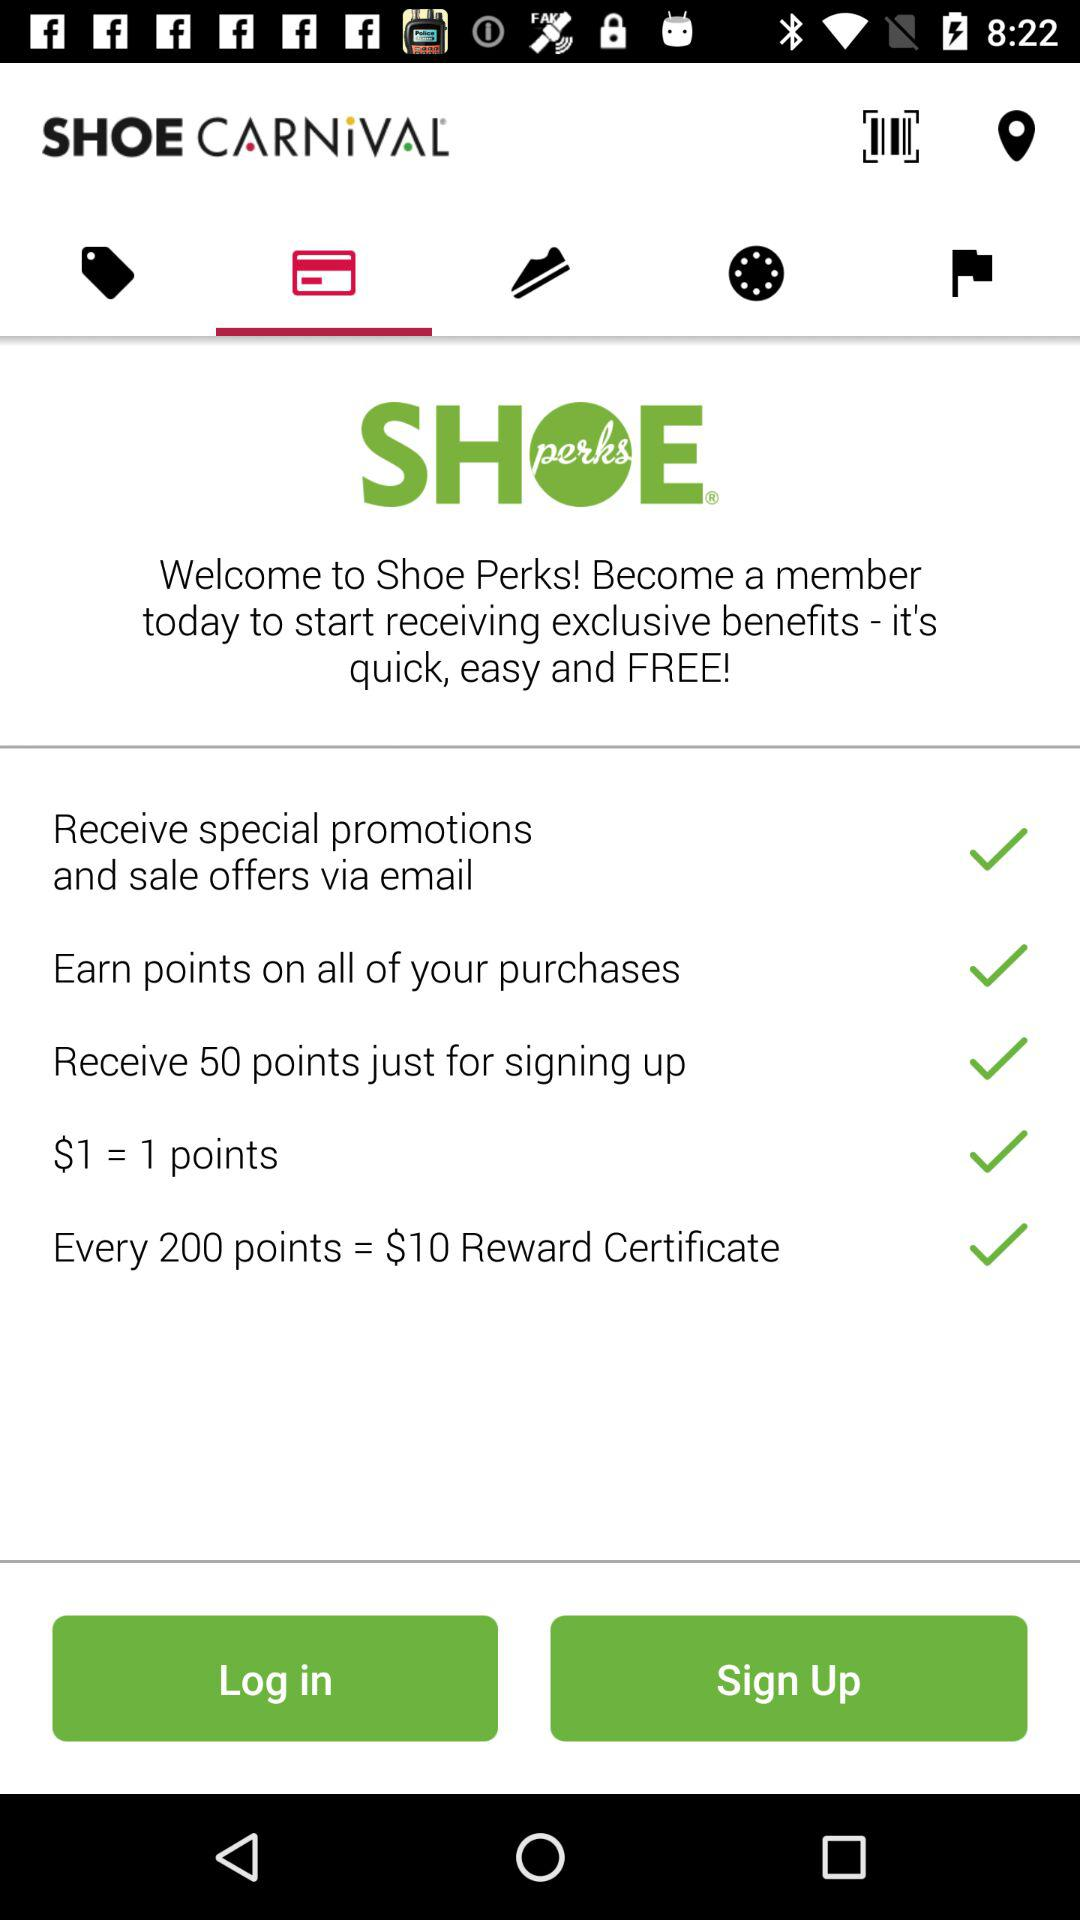What is the application name? The application name is "SHOE CARNIVAL". 